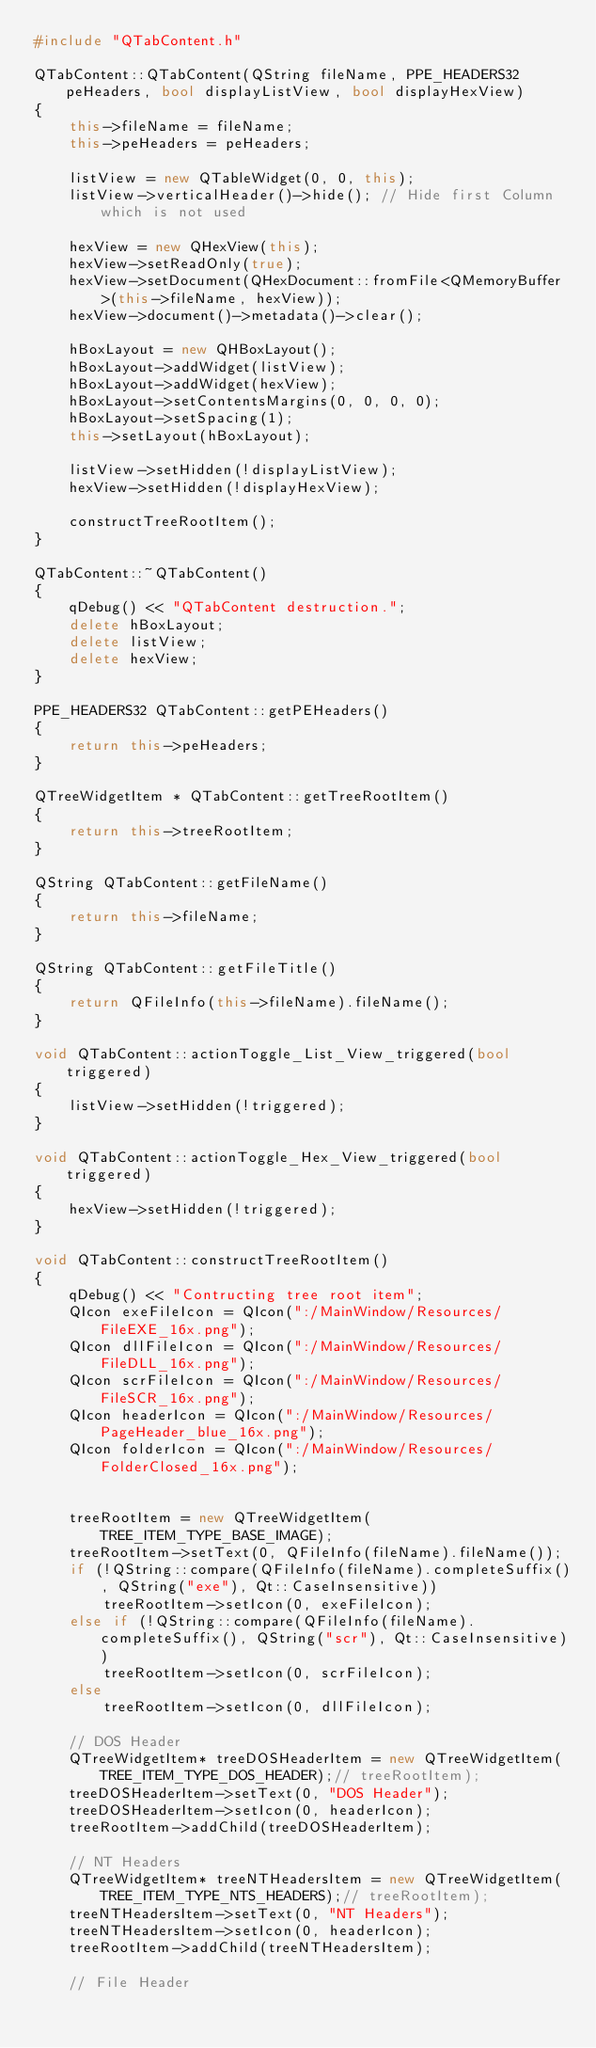Convert code to text. <code><loc_0><loc_0><loc_500><loc_500><_C++_>#include "QTabContent.h"

QTabContent::QTabContent(QString fileName, PPE_HEADERS32 peHeaders, bool displayListView, bool displayHexView)
{
	this->fileName = fileName;
	this->peHeaders = peHeaders;

	listView = new QTableWidget(0, 0, this);
	listView->verticalHeader()->hide(); // Hide first Column which is not used

	hexView = new QHexView(this);
	hexView->setReadOnly(true);
	hexView->setDocument(QHexDocument::fromFile<QMemoryBuffer>(this->fileName, hexView));
	hexView->document()->metadata()->clear();

	hBoxLayout = new QHBoxLayout();
	hBoxLayout->addWidget(listView);
	hBoxLayout->addWidget(hexView);
	hBoxLayout->setContentsMargins(0, 0, 0, 0);
	hBoxLayout->setSpacing(1);
	this->setLayout(hBoxLayout);

	listView->setHidden(!displayListView);
	hexView->setHidden(!displayHexView);

	constructTreeRootItem();
}

QTabContent::~QTabContent()
{
	qDebug() << "QTabContent destruction.";
	delete hBoxLayout;
	delete listView;
	delete hexView;
}

PPE_HEADERS32 QTabContent::getPEHeaders()
{
	return this->peHeaders;
}

QTreeWidgetItem * QTabContent::getTreeRootItem()
{
	return this->treeRootItem;
}

QString QTabContent::getFileName()
{
	return this->fileName;
}

QString QTabContent::getFileTitle()
{
	return QFileInfo(this->fileName).fileName();
}

void QTabContent::actionToggle_List_View_triggered(bool triggered)
{
	listView->setHidden(!triggered);
}

void QTabContent::actionToggle_Hex_View_triggered(bool triggered)
{
	hexView->setHidden(!triggered);
}

void QTabContent::constructTreeRootItem()
{
	qDebug() << "Contructing tree root item";
	QIcon exeFileIcon = QIcon(":/MainWindow/Resources/FileEXE_16x.png");
	QIcon dllFileIcon = QIcon(":/MainWindow/Resources/FileDLL_16x.png");
	QIcon scrFileIcon = QIcon(":/MainWindow/Resources/FileSCR_16x.png");
	QIcon headerIcon = QIcon(":/MainWindow/Resources/PageHeader_blue_16x.png");
	QIcon folderIcon = QIcon(":/MainWindow/Resources/FolderClosed_16x.png");


	treeRootItem = new QTreeWidgetItem(TREE_ITEM_TYPE_BASE_IMAGE);
	treeRootItem->setText(0, QFileInfo(fileName).fileName());
	if (!QString::compare(QFileInfo(fileName).completeSuffix(), QString("exe"), Qt::CaseInsensitive))
		treeRootItem->setIcon(0, exeFileIcon);
	else if (!QString::compare(QFileInfo(fileName).completeSuffix(), QString("scr"), Qt::CaseInsensitive))
		treeRootItem->setIcon(0, scrFileIcon);
	else
		treeRootItem->setIcon(0, dllFileIcon);

	// DOS Header
	QTreeWidgetItem* treeDOSHeaderItem = new QTreeWidgetItem(TREE_ITEM_TYPE_DOS_HEADER);// treeRootItem);
	treeDOSHeaderItem->setText(0, "DOS Header");
	treeDOSHeaderItem->setIcon(0, headerIcon);
	treeRootItem->addChild(treeDOSHeaderItem);

	// NT Headers
	QTreeWidgetItem* treeNTHeadersItem = new QTreeWidgetItem(TREE_ITEM_TYPE_NTS_HEADERS);// treeRootItem);
	treeNTHeadersItem->setText(0, "NT Headers");
	treeNTHeadersItem->setIcon(0, headerIcon);
	treeRootItem->addChild(treeNTHeadersItem);

	// File Header</code> 